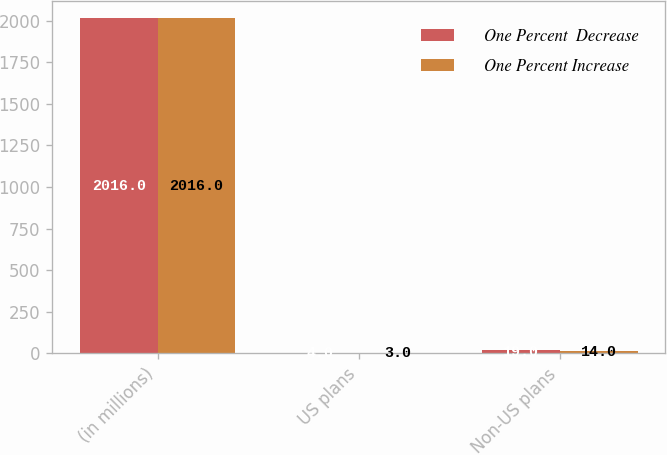Convert chart. <chart><loc_0><loc_0><loc_500><loc_500><stacked_bar_chart><ecel><fcel>(in millions)<fcel>US plans<fcel>Non-US plans<nl><fcel>One Percent  Decrease<fcel>2016<fcel>4<fcel>19<nl><fcel>One Percent Increase<fcel>2016<fcel>3<fcel>14<nl></chart> 